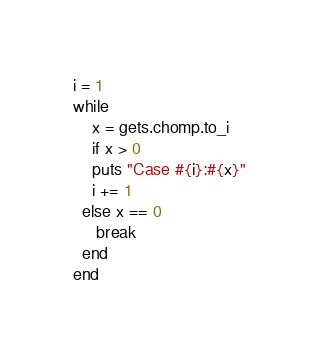Convert code to text. <code><loc_0><loc_0><loc_500><loc_500><_Ruby_>i = 1
while
    x = gets.chomp.to_i
    if x > 0
    puts "Case #{i}:#{x}"
    i += 1
  else x == 0
     break
  end
end</code> 